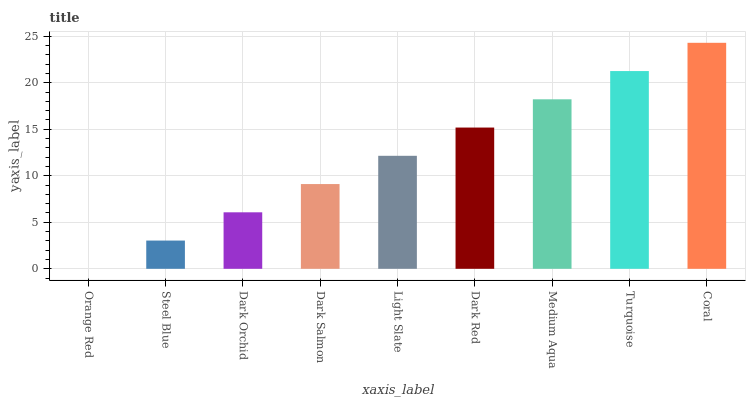Is Orange Red the minimum?
Answer yes or no. Yes. Is Coral the maximum?
Answer yes or no. Yes. Is Steel Blue the minimum?
Answer yes or no. No. Is Steel Blue the maximum?
Answer yes or no. No. Is Steel Blue greater than Orange Red?
Answer yes or no. Yes. Is Orange Red less than Steel Blue?
Answer yes or no. Yes. Is Orange Red greater than Steel Blue?
Answer yes or no. No. Is Steel Blue less than Orange Red?
Answer yes or no. No. Is Light Slate the high median?
Answer yes or no. Yes. Is Light Slate the low median?
Answer yes or no. Yes. Is Dark Red the high median?
Answer yes or no. No. Is Steel Blue the low median?
Answer yes or no. No. 